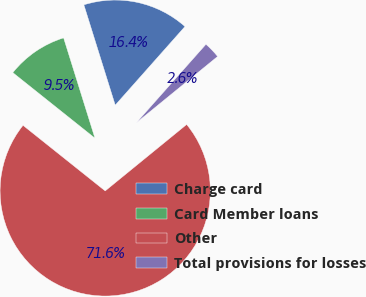<chart> <loc_0><loc_0><loc_500><loc_500><pie_chart><fcel>Charge card<fcel>Card Member loans<fcel>Other<fcel>Total provisions for losses<nl><fcel>16.37%<fcel>9.46%<fcel>71.61%<fcel>2.56%<nl></chart> 